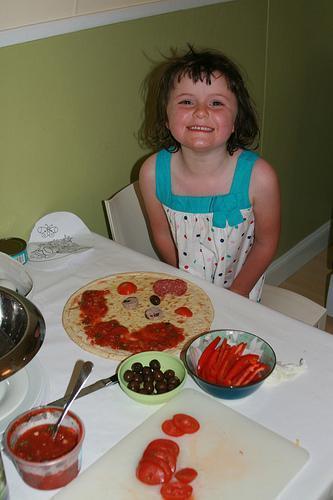How many bowls are pictured?
Give a very brief answer. 4. How many people are in the picture?
Give a very brief answer. 1. 